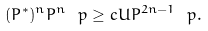Convert formula to latex. <formula><loc_0><loc_0><loc_500><loc_500>( P ^ { * } ) ^ { n } P ^ { n } \ p \geq c U P ^ { 2 n - 1 } \ p .</formula> 